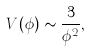<formula> <loc_0><loc_0><loc_500><loc_500>V ( \phi ) \sim \frac { 3 } { \phi ^ { 2 } } ,</formula> 